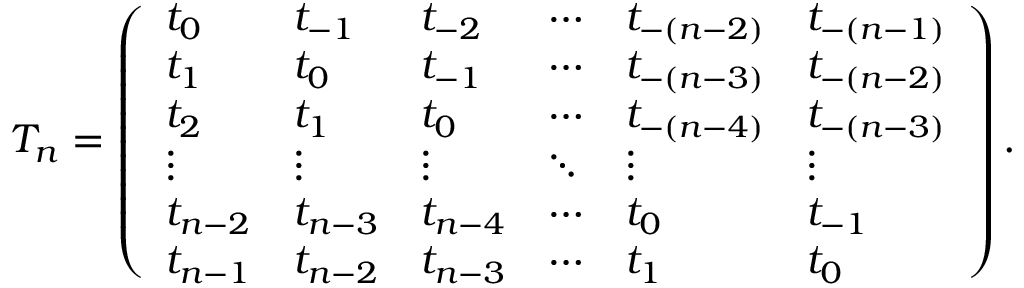Convert formula to latex. <formula><loc_0><loc_0><loc_500><loc_500>T _ { n } = \left ( \begin{array} { l l l l l l } { t _ { 0 } } & { t _ { - 1 } } & { t _ { - 2 } } & { \cdots } & { t _ { - ( n - 2 ) } } & { t _ { - ( n - 1 ) } } \\ { t _ { 1 } } & { t _ { 0 } } & { t _ { - 1 } } & { \cdots } & { t _ { - ( n - 3 ) } } & { t _ { - ( n - 2 ) } } \\ { t _ { 2 } } & { t _ { 1 } } & { t _ { 0 } } & { \cdots } & { t _ { - ( n - 4 ) } } & { t _ { - ( n - 3 ) } } \\ { \vdots } & { \vdots } & { \vdots } & { \ddots } & { \vdots } & { \vdots } \\ { t _ { n - 2 } } & { t _ { n - 3 } } & { t _ { n - 4 } } & { \cdots } & { t _ { 0 } } & { t _ { - 1 } } \\ { t _ { n - 1 } } & { t _ { n - 2 } } & { t _ { n - 3 } } & { \cdots } & { t _ { 1 } } & { t _ { 0 } } \end{array} \right ) .</formula> 